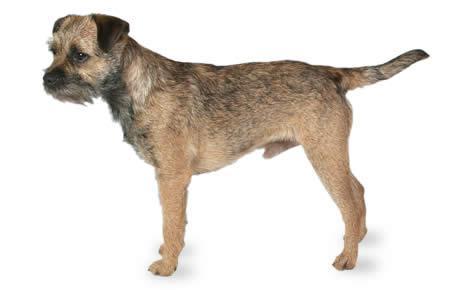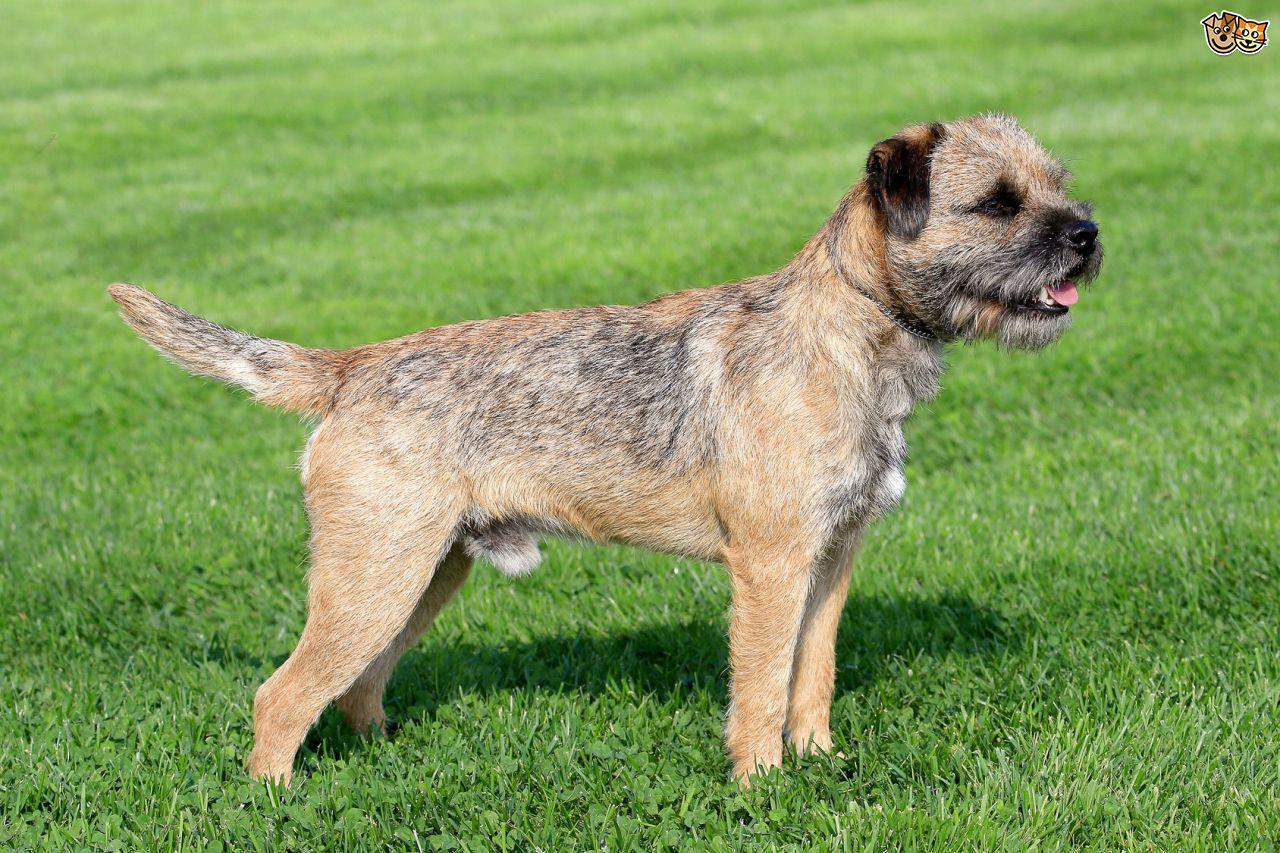The first image is the image on the left, the second image is the image on the right. For the images displayed, is the sentence "The dogs in the images are standing with bodies turned in opposite directions." factually correct? Answer yes or no. Yes. 